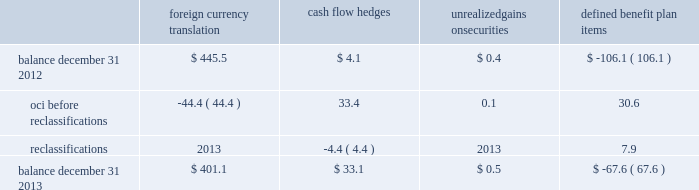Zimmer holdings , inc .
2013 form 10-k annual report notes to consolidated financial statements ( continued ) we have four tranches of senior notes outstanding : $ 250 million aggregate principal amount of 1.4 percent notes due november 30 , 2014 , $ 500 million aggregate principal amount of 4.625 percent notes due november 30 , 2019 , $ 300 million aggregate principal amount of 3.375 percent notes due november 30 , 2021 and $ 500 million aggregate principal amount of 5.75 percent notes due november 30 , 2039 .
Interest on each series is payable on may 30 and november 30 of each year until maturity .
The estimated fair value of our senior notes as of december 31 , 2013 , based on quoted prices for the specific securities from transactions in over-the-counter markets ( level 2 ) , was $ 1649.5 million .
We may redeem the senior notes at our election in whole or in part at any time prior to maturity at a redemption price equal to the greater of 1 ) 100 percent of the principal amount of the notes being redeemed ; or 2 ) the sum of the present values of the remaining scheduled payments of principal and interest ( not including any portion of such payments of interest accrued as of the date of redemption ) , discounted to the date of redemption on a semi-annual basis at the treasury rate ( as defined in the debt agreement ) , plus 15 basis points in the case of the 2014 notes , 20 basis points in the case of the 2019 notes and 2021 notes , and 25 basis points in the case of the 2039 notes .
We would also pay the accrued and unpaid interest on the senior notes to the redemption date .
We have entered into interest rate swap agreements which we designated as fair value hedges of underlying fixed- rate obligations on our senior notes due 2019 and 2021 .
See note 13 for additional information regarding the interest rate swap agreements .
Before our senior notes due november 30 , 2014 become payable , we intend to issue new senior notes in order to pay the $ 250 million owed .
If we are not able to issue new senior notes , we intend to borrow against our senior credit facility to pay these notes .
Since we have the ability and intent to refinance these senior notes on a long-term basis with new notes or through our senior credit facility , we have classified these senior notes as long-term debt as of december 31 , 2013 .
We also have available uncommitted credit facilities totaling $ 50.7 million .
At december 31 , 2013 , the weighted average interest rate for our long-term borrowings was 3.3 percent .
At december 31 , 2012 , the weighted average interest rate for short-term and long-term borrowings was 1.1 percent and 3.5 percent , respectively .
We paid $ 68.1 million , $ 67.8 million and $ 55.0 million in interest during 2013 , 2012 and 2011 , respectively .
12 .
Accumulated other comprehensive income oci refers to certain gains and losses that under gaap are included in comprehensive income but are excluded from net earnings as these amounts are initially recorded as an adjustment to stockholders 2019 equity .
Amounts in oci may be reclassified to net earnings upon the occurrence of certain events .
Our oci is comprised of foreign currency translation adjustments , unrealized gains and losses on cash flow hedges , unrealized gains and losses on available-for-sale securities , and amortization of prior service costs and unrecognized gains and losses in actuarial assumptions on our defined benefit plans .
Foreign currency translation adjustments are reclassified to net earnings upon sale or upon a complete or substantially complete liquidation of an investment in a foreign entity .
Unrealized gains and losses on cash flow hedges are reclassified to net earnings when the hedged item affects net earnings .
Unrealized gains and losses on available-for-sale securities are reclassified to net earnings if we sell the security before maturity or if the unrealized loss is considered to be other-than-temporary .
We typically hold our available-for-sale securities until maturity and are able to realize their amortized cost and therefore we do not have reclassification adjustments to net earnings on these securities .
Amounts related to defined benefit plans that are in oci are reclassified over the service periods of employees in the plan .
The reclassification amounts are allocated to all employees in the plans and therefore the reclassified amounts may become part of inventory to the extent they are considered direct labor costs .
See note 14 for more information on our defined benefit plans .
The table shows the changes in the components of oci , net of tax ( in millions ) : foreign currency translation hedges unrealized gains on securities defined benefit .

What was the change in interest paid between 2012 and 2013 in millions? 
Computations: (68.1 - 67.8)
Answer: 0.3. 